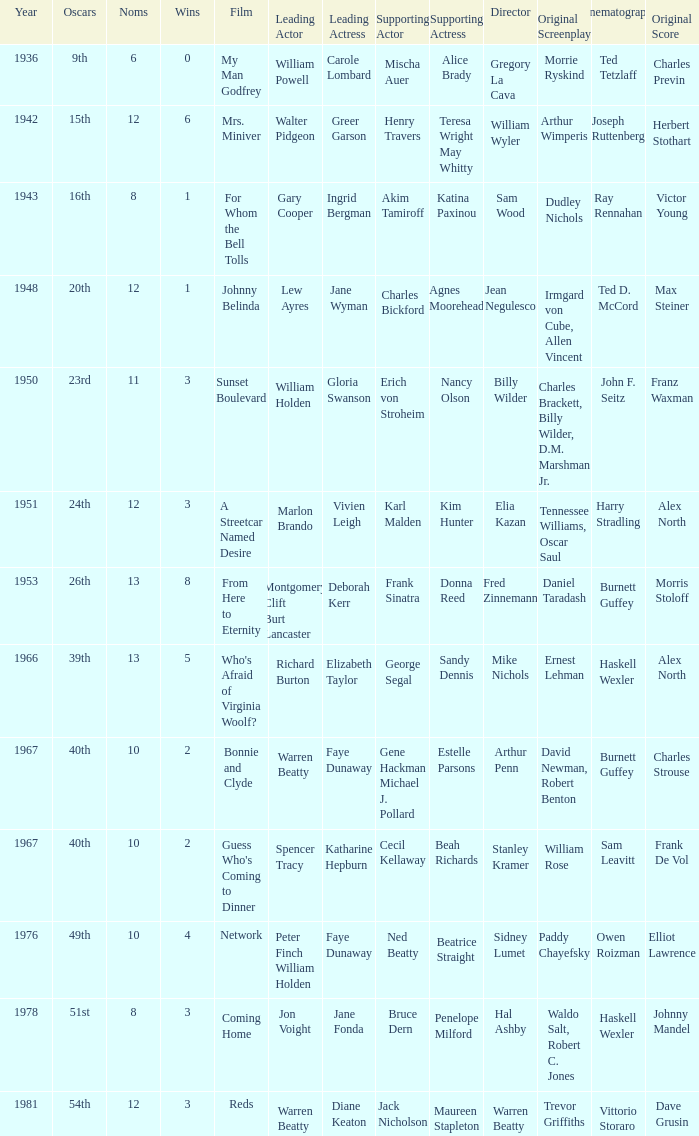Which film had Charles Bickford as supporting actor? Johnny Belinda. 